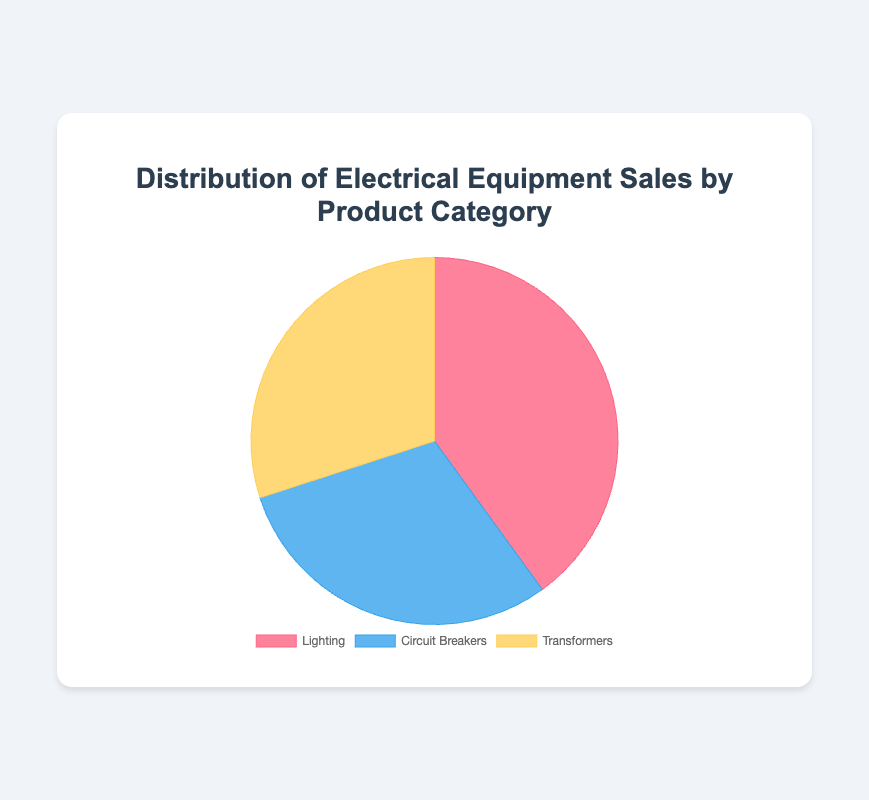What product category has the highest sales value? The label and the size of the pie slice indicate that "Lighting" has the highest sales value among the three categories: Lighting, Circuit Breakers, and Transformers.
Answer: Lighting How much more in sales does Lighting have compared to Circuit Breakers? Lighting has $400,000 in sales, while Circuit Breakers have $300,000 in sales. The difference is $400,000 - $300,000.
Answer: $100,000 What is the total sales value of Circuit Breakers and Transformers combined? The sales value of Circuit Breakers is $300,000, and the sales value of Transformers is also $300,000. The total combined sales value is $300,000 + $300,000.
Answer: $600,000 What is the percentage share of Transformer sales in the total sales? The Transformer sales value is $300,000, and the total sales value is $1,000,000. The percentage is calculated as (300,000 / 1,000,000) * 100%.
Answer: 30% Which product category has the smallest sales value? By observing the size of the pie slices and their labels, it's clear that Circuit Breakers and Transformers have equal and smaller sales values compared to Lighting. However, neither is smallest since both are equal.
Answer: Circuit Breakers, Transformers What are the colors associated with each product category in the pie chart? The visual attributes of the pie chart show three distinct colors: one for each category's slice. Lighting is represented in red, Circuit Breakers in blue, and Transformers in yellow.
Answer: Lighting: red, Circuit Breakers: blue, Transformers: yellow How much less in sales do Circuit Breakers have compared to the total combined sales of Lighting and Transformers? The total sales for Lighting and Transformers combined is $700,000 ($400,000 + $300,000). Circuit Breakers have $300,000 in sales. The difference is $700,000 - $300,000.
Answer: $400,000 What is the percentage sales difference between the highest and the lowest sales categories? Lighting has the highest sales at $400,000, and the lowest categories (Circuit Breakers and Transformers) have $300,000. The difference is $100,000. The percentage difference is ($100,000 / $1,000,000) * 100%.
Answer: 10% What is the average sales value of the three product categories? The total sales value is $1,000,000. There are three categories. The average is $1,000,000 / 3.
Answer: $333,333.33 If Circuit Breakers and Transformers sales increased by 10%, what would their new combined sales value be? Circuit Breakers and Transformers each have $300,000 in sales. If both increased by 10%, their individual sales would be $300,000 * 1.1 = $330,000 each. The combined value is $330,000 + $330,000.
Answer: $660,000 